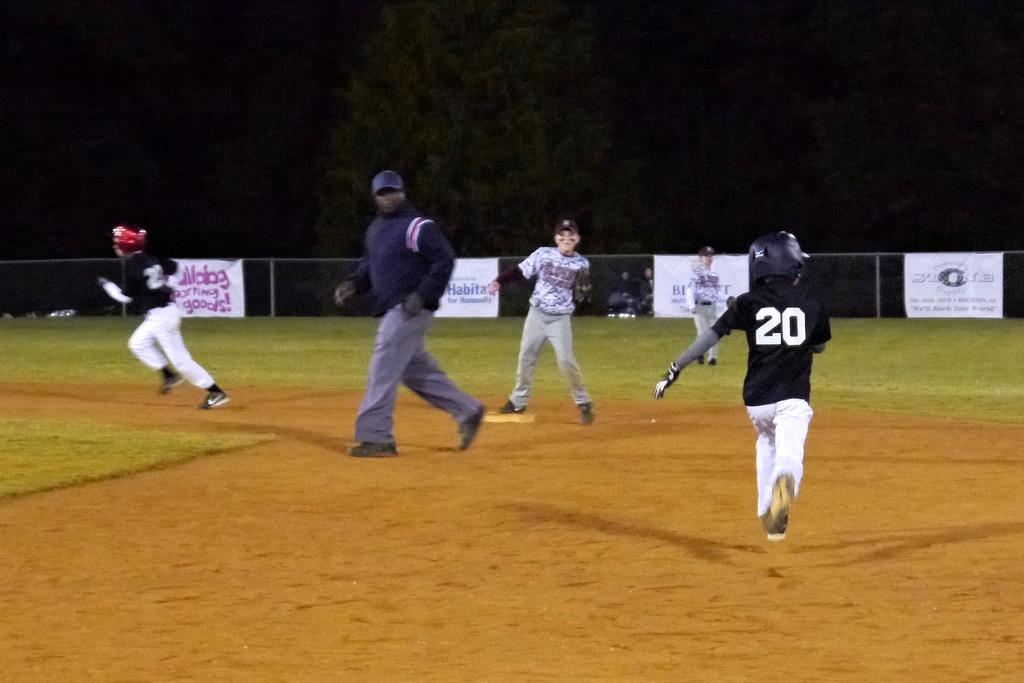Provide a one-sentence caption for the provided image. Baseball field with a Habitat for Humanity banner on the fence. 